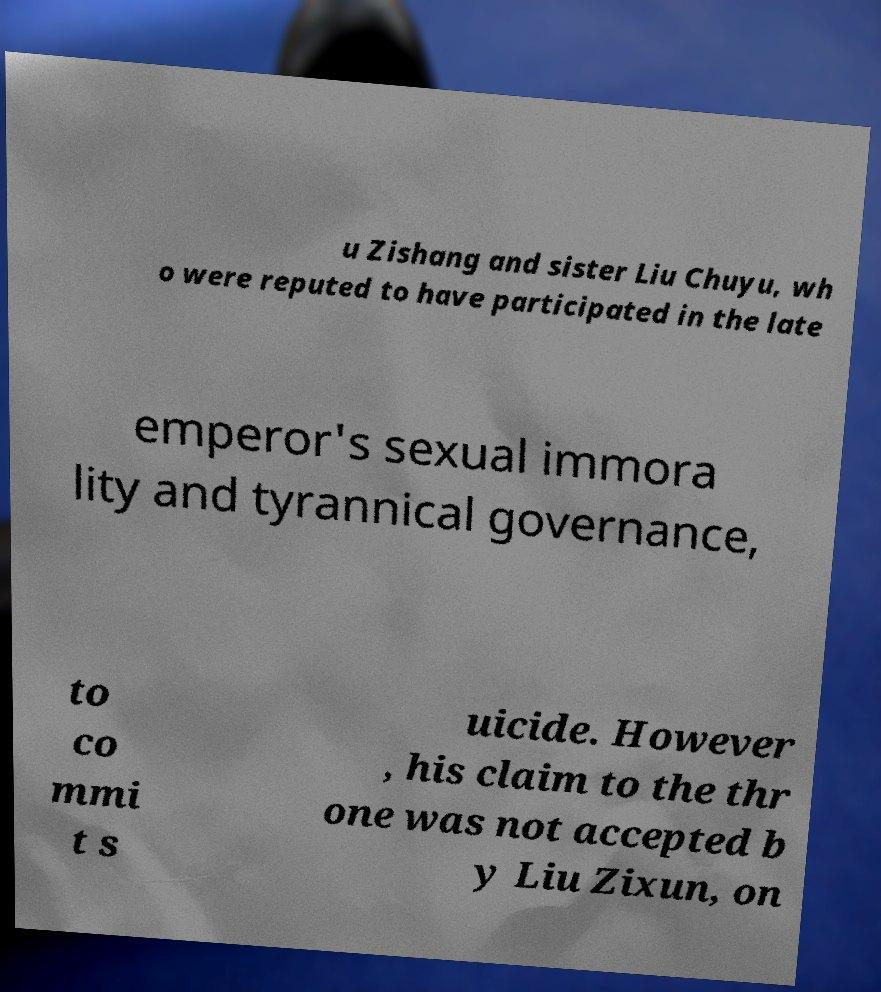What messages or text are displayed in this image? I need them in a readable, typed format. u Zishang and sister Liu Chuyu, wh o were reputed to have participated in the late emperor's sexual immora lity and tyrannical governance, to co mmi t s uicide. However , his claim to the thr one was not accepted b y Liu Zixun, on 